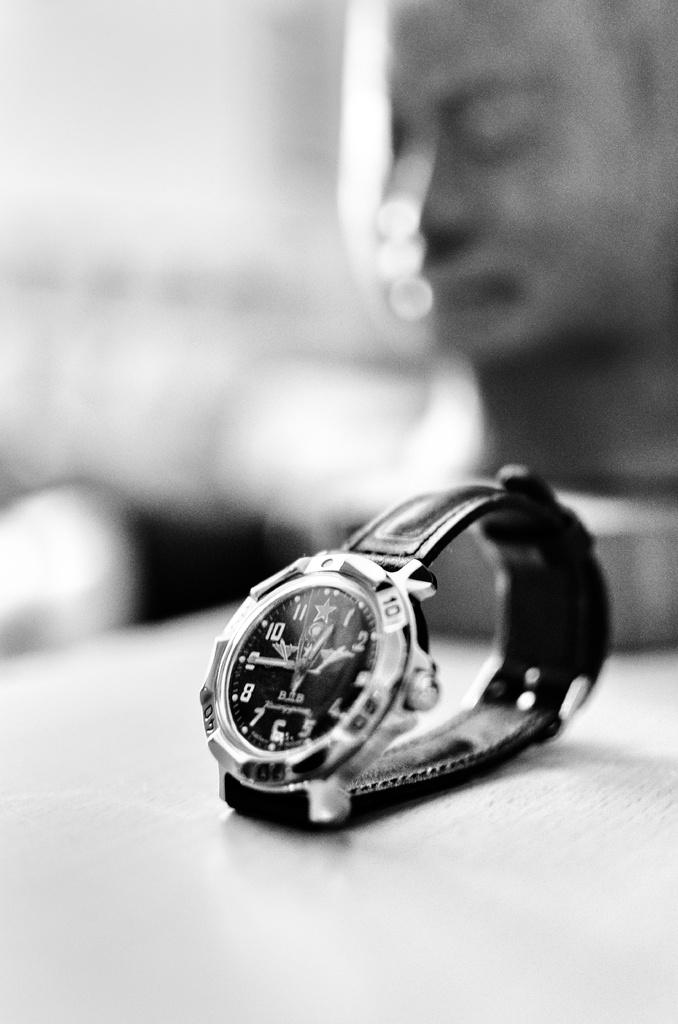Provide a one-sentence caption for the provided image. A watch that is showing the time as 12:45. 